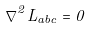<formula> <loc_0><loc_0><loc_500><loc_500>\nabla ^ { 2 } L _ { a b c } = 0</formula> 